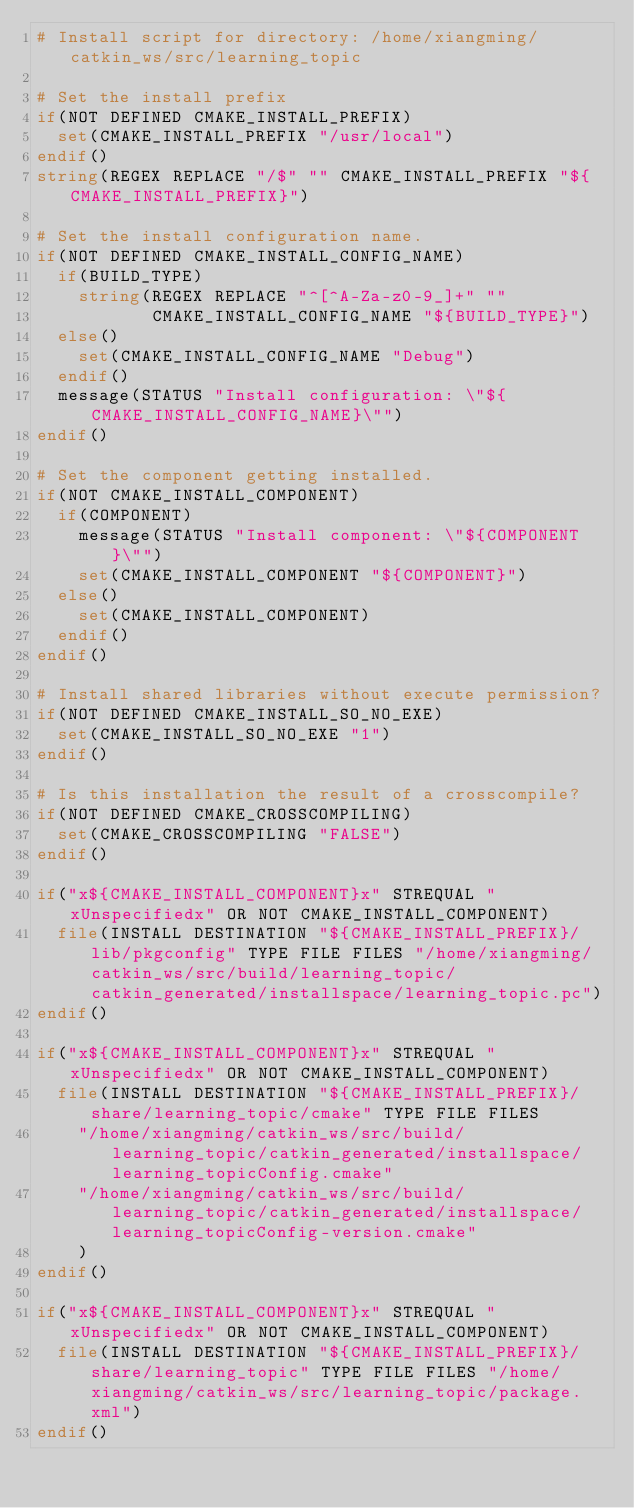Convert code to text. <code><loc_0><loc_0><loc_500><loc_500><_CMake_># Install script for directory: /home/xiangming/catkin_ws/src/learning_topic

# Set the install prefix
if(NOT DEFINED CMAKE_INSTALL_PREFIX)
  set(CMAKE_INSTALL_PREFIX "/usr/local")
endif()
string(REGEX REPLACE "/$" "" CMAKE_INSTALL_PREFIX "${CMAKE_INSTALL_PREFIX}")

# Set the install configuration name.
if(NOT DEFINED CMAKE_INSTALL_CONFIG_NAME)
  if(BUILD_TYPE)
    string(REGEX REPLACE "^[^A-Za-z0-9_]+" ""
           CMAKE_INSTALL_CONFIG_NAME "${BUILD_TYPE}")
  else()
    set(CMAKE_INSTALL_CONFIG_NAME "Debug")
  endif()
  message(STATUS "Install configuration: \"${CMAKE_INSTALL_CONFIG_NAME}\"")
endif()

# Set the component getting installed.
if(NOT CMAKE_INSTALL_COMPONENT)
  if(COMPONENT)
    message(STATUS "Install component: \"${COMPONENT}\"")
    set(CMAKE_INSTALL_COMPONENT "${COMPONENT}")
  else()
    set(CMAKE_INSTALL_COMPONENT)
  endif()
endif()

# Install shared libraries without execute permission?
if(NOT DEFINED CMAKE_INSTALL_SO_NO_EXE)
  set(CMAKE_INSTALL_SO_NO_EXE "1")
endif()

# Is this installation the result of a crosscompile?
if(NOT DEFINED CMAKE_CROSSCOMPILING)
  set(CMAKE_CROSSCOMPILING "FALSE")
endif()

if("x${CMAKE_INSTALL_COMPONENT}x" STREQUAL "xUnspecifiedx" OR NOT CMAKE_INSTALL_COMPONENT)
  file(INSTALL DESTINATION "${CMAKE_INSTALL_PREFIX}/lib/pkgconfig" TYPE FILE FILES "/home/xiangming/catkin_ws/src/build/learning_topic/catkin_generated/installspace/learning_topic.pc")
endif()

if("x${CMAKE_INSTALL_COMPONENT}x" STREQUAL "xUnspecifiedx" OR NOT CMAKE_INSTALL_COMPONENT)
  file(INSTALL DESTINATION "${CMAKE_INSTALL_PREFIX}/share/learning_topic/cmake" TYPE FILE FILES
    "/home/xiangming/catkin_ws/src/build/learning_topic/catkin_generated/installspace/learning_topicConfig.cmake"
    "/home/xiangming/catkin_ws/src/build/learning_topic/catkin_generated/installspace/learning_topicConfig-version.cmake"
    )
endif()

if("x${CMAKE_INSTALL_COMPONENT}x" STREQUAL "xUnspecifiedx" OR NOT CMAKE_INSTALL_COMPONENT)
  file(INSTALL DESTINATION "${CMAKE_INSTALL_PREFIX}/share/learning_topic" TYPE FILE FILES "/home/xiangming/catkin_ws/src/learning_topic/package.xml")
endif()

</code> 